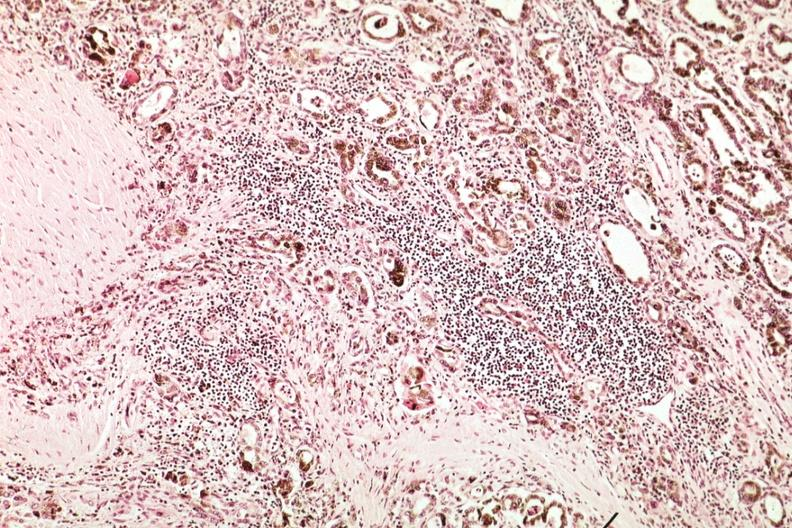s vasculature present?
Answer the question using a single word or phrase. No 